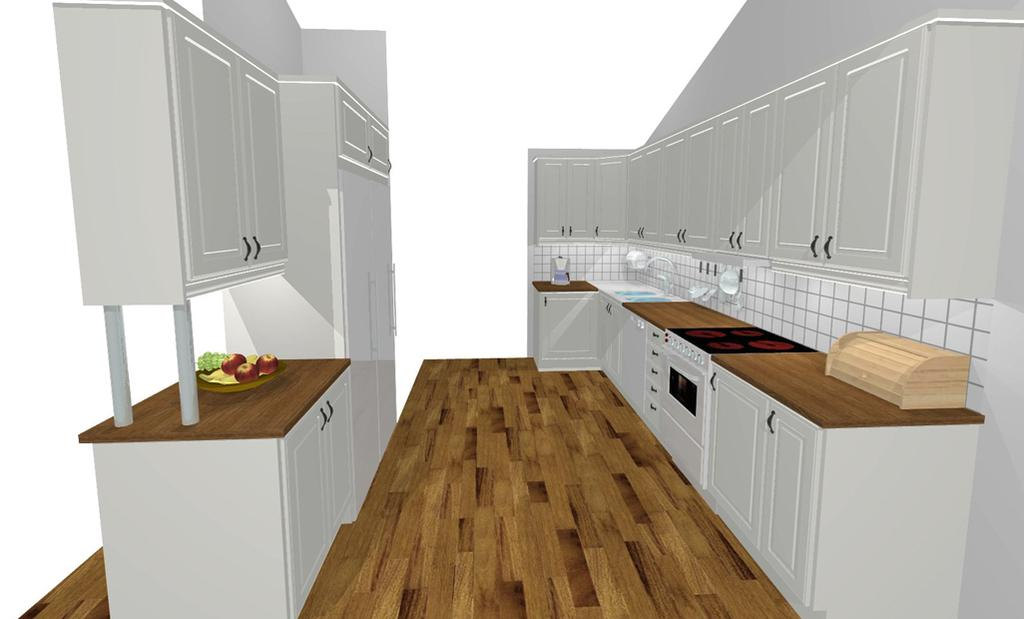What type of furniture is shown in the image? There are shelves with doors in the image. What food items can be seen on a plate in the image? There are fruits on a plate in the image. What is the surface beneath the shelves and plate in the image? The bottom of the image contains a floor. What shape is the daughter's toy in the image? There is no daughter or toy present in the image. 